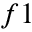<formula> <loc_0><loc_0><loc_500><loc_500>f 1</formula> 